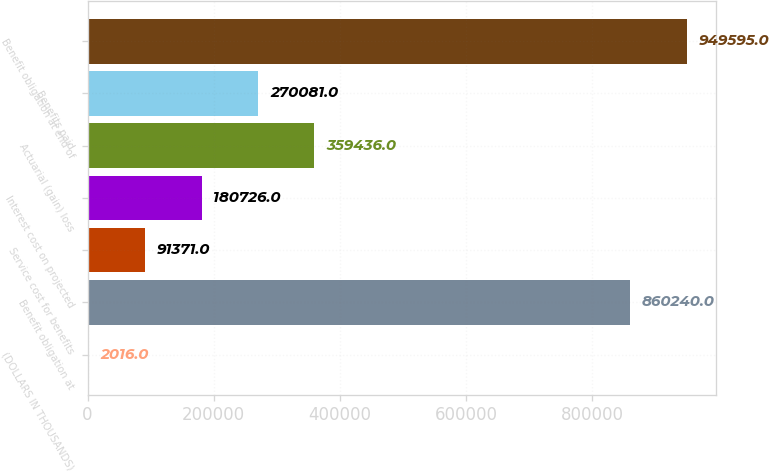Convert chart to OTSL. <chart><loc_0><loc_0><loc_500><loc_500><bar_chart><fcel>(DOLLARS IN THOUSANDS)<fcel>Benefit obligation at<fcel>Service cost for benefits<fcel>Interest cost on projected<fcel>Actuarial (gain) loss<fcel>Benefits paid<fcel>Benefit obligation at end of<nl><fcel>2016<fcel>860240<fcel>91371<fcel>180726<fcel>359436<fcel>270081<fcel>949595<nl></chart> 